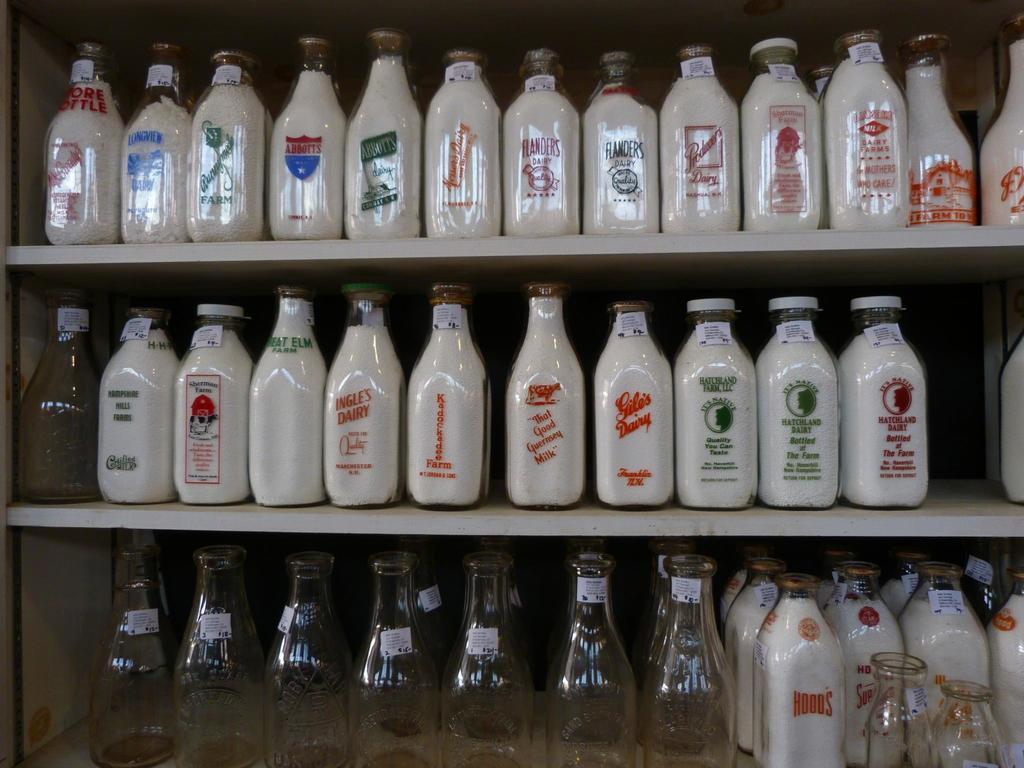<image>
Share a concise interpretation of the image provided. A milk bottle from Gile's Dairy has red text on it and is with many other milk bottles. 